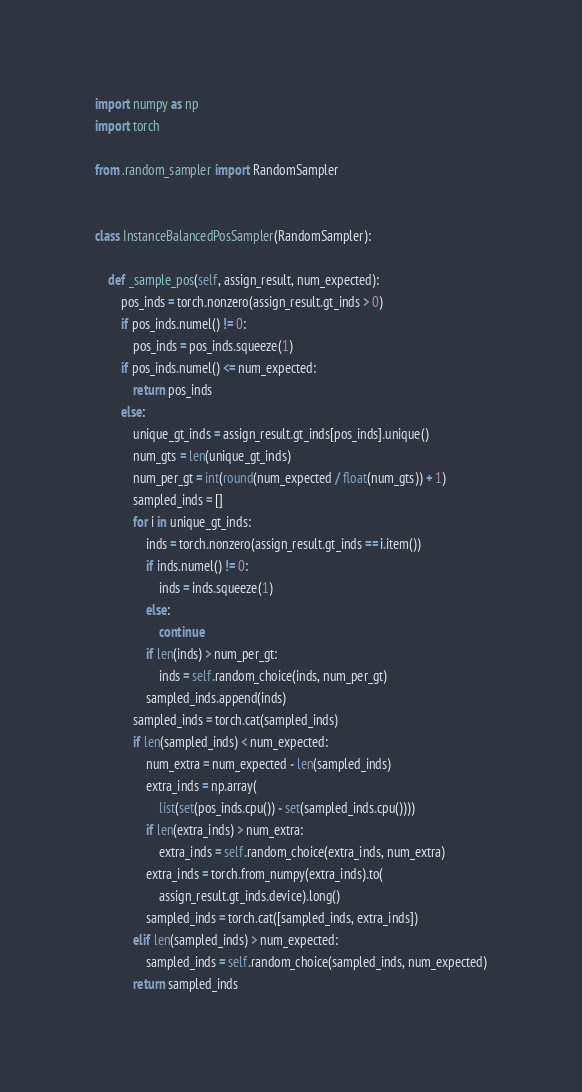<code> <loc_0><loc_0><loc_500><loc_500><_Python_>import numpy as np
import torch

from .random_sampler import RandomSampler


class InstanceBalancedPosSampler(RandomSampler):

    def _sample_pos(self, assign_result, num_expected):
        pos_inds = torch.nonzero(assign_result.gt_inds > 0)
        if pos_inds.numel() != 0:
            pos_inds = pos_inds.squeeze(1)
        if pos_inds.numel() <= num_expected:
            return pos_inds
        else:
            unique_gt_inds = assign_result.gt_inds[pos_inds].unique()
            num_gts = len(unique_gt_inds)
            num_per_gt = int(round(num_expected / float(num_gts)) + 1)
            sampled_inds = []
            for i in unique_gt_inds:
                inds = torch.nonzero(assign_result.gt_inds == i.item())
                if inds.numel() != 0:
                    inds = inds.squeeze(1)
                else:
                    continue
                if len(inds) > num_per_gt:
                    inds = self.random_choice(inds, num_per_gt)
                sampled_inds.append(inds)
            sampled_inds = torch.cat(sampled_inds)
            if len(sampled_inds) < num_expected:
                num_extra = num_expected - len(sampled_inds)
                extra_inds = np.array(
                    list(set(pos_inds.cpu()) - set(sampled_inds.cpu())))
                if len(extra_inds) > num_extra:
                    extra_inds = self.random_choice(extra_inds, num_extra)
                extra_inds = torch.from_numpy(extra_inds).to(
                    assign_result.gt_inds.device).long()
                sampled_inds = torch.cat([sampled_inds, extra_inds])
            elif len(sampled_inds) > num_expected:
                sampled_inds = self.random_choice(sampled_inds, num_expected)
            return sampled_inds
</code> 